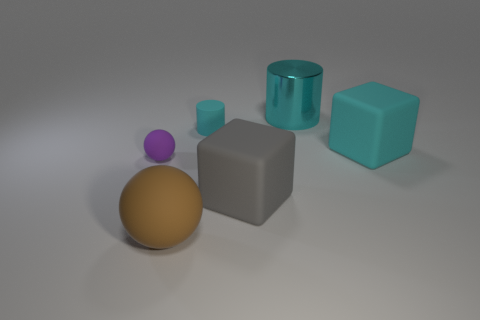How many gray objects are either matte objects or tiny matte things?
Keep it short and to the point. 1. The cyan metallic thing that is the same size as the gray thing is what shape?
Your answer should be very brief. Cylinder. What number of other objects are the same color as the big metallic object?
Make the answer very short. 2. What size is the cylinder to the left of the big rubber cube to the left of the large shiny cylinder?
Your response must be concise. Small. Are the object behind the small cylinder and the brown ball made of the same material?
Keep it short and to the point. No. The matte object right of the gray rubber cube has what shape?
Ensure brevity in your answer.  Cube. How many yellow blocks are the same size as the brown object?
Offer a terse response. 0. The cyan cube is what size?
Provide a short and direct response. Large. There is a large cyan matte cube; how many cyan metallic cylinders are in front of it?
Offer a terse response. 0. What is the shape of the tiny cyan object that is made of the same material as the purple sphere?
Give a very brief answer. Cylinder. 